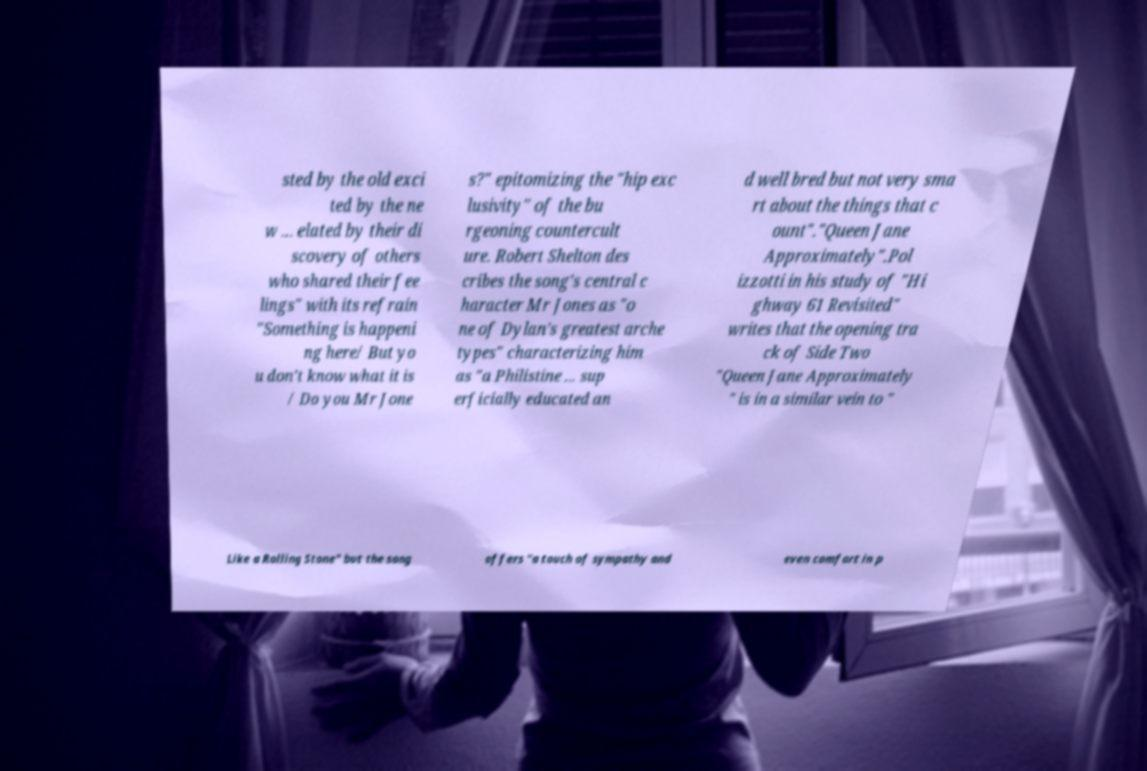Could you assist in decoding the text presented in this image and type it out clearly? sted by the old exci ted by the ne w ... elated by their di scovery of others who shared their fee lings" with its refrain "Something is happeni ng here/ But yo u don't know what it is / Do you Mr Jone s?" epitomizing the "hip exc lusivity" of the bu rgeoning countercult ure. Robert Shelton des cribes the song's central c haracter Mr Jones as "o ne of Dylan's greatest arche types" characterizing him as "a Philistine ... sup erficially educated an d well bred but not very sma rt about the things that c ount"."Queen Jane Approximately".Pol izzotti in his study of "Hi ghway 61 Revisited" writes that the opening tra ck of Side Two "Queen Jane Approximately " is in a similar vein to " Like a Rolling Stone" but the song offers "a touch of sympathy and even comfort in p 